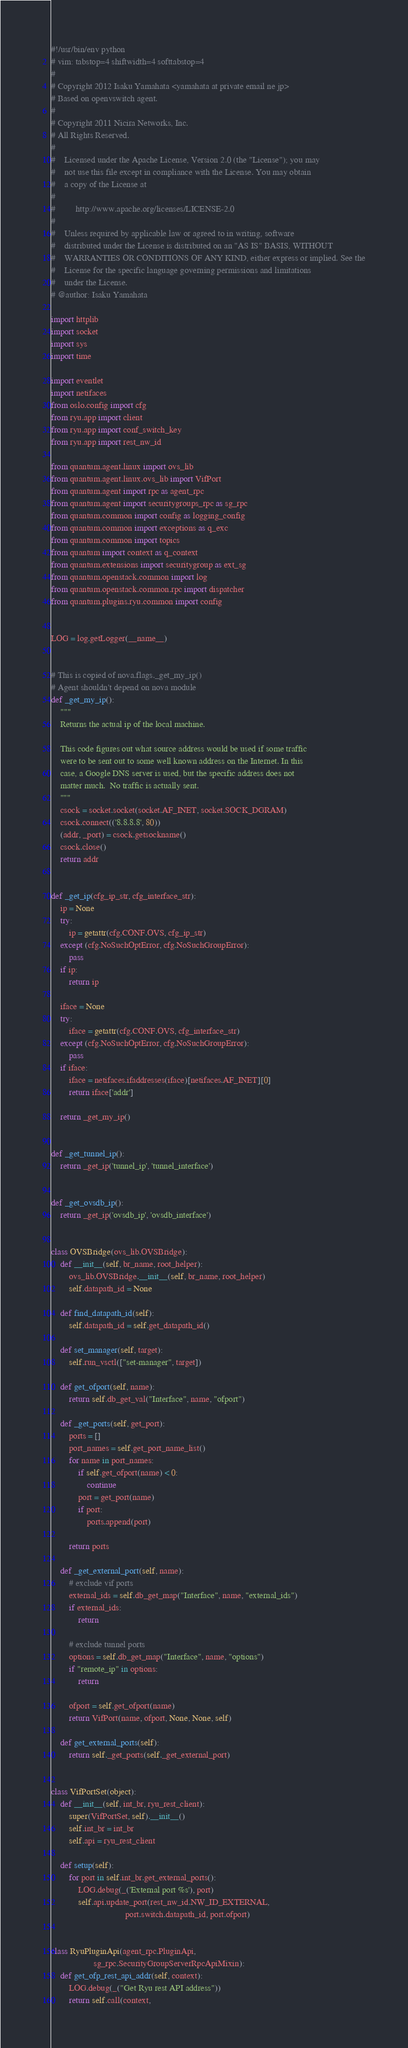Convert code to text. <code><loc_0><loc_0><loc_500><loc_500><_Python_>#!/usr/bin/env python
# vim: tabstop=4 shiftwidth=4 softtabstop=4
#
# Copyright 2012 Isaku Yamahata <yamahata at private email ne jp>
# Based on openvswitch agent.
#
# Copyright 2011 Nicira Networks, Inc.
# All Rights Reserved.
#
#    Licensed under the Apache License, Version 2.0 (the "License"); you may
#    not use this file except in compliance with the License. You may obtain
#    a copy of the License at
#
#         http://www.apache.org/licenses/LICENSE-2.0
#
#    Unless required by applicable law or agreed to in writing, software
#    distributed under the License is distributed on an "AS IS" BASIS, WITHOUT
#    WARRANTIES OR CONDITIONS OF ANY KIND, either express or implied. See the
#    License for the specific language governing permissions and limitations
#    under the License.
# @author: Isaku Yamahata

import httplib
import socket
import sys
import time

import eventlet
import netifaces
from oslo.config import cfg
from ryu.app import client
from ryu.app import conf_switch_key
from ryu.app import rest_nw_id

from quantum.agent.linux import ovs_lib
from quantum.agent.linux.ovs_lib import VifPort
from quantum.agent import rpc as agent_rpc
from quantum.agent import securitygroups_rpc as sg_rpc
from quantum.common import config as logging_config
from quantum.common import exceptions as q_exc
from quantum.common import topics
from quantum import context as q_context
from quantum.extensions import securitygroup as ext_sg
from quantum.openstack.common import log
from quantum.openstack.common.rpc import dispatcher
from quantum.plugins.ryu.common import config


LOG = log.getLogger(__name__)


# This is copied of nova.flags._get_my_ip()
# Agent shouldn't depend on nova module
def _get_my_ip():
    """
    Returns the actual ip of the local machine.

    This code figures out what source address would be used if some traffic
    were to be sent out to some well known address on the Internet. In this
    case, a Google DNS server is used, but the specific address does not
    matter much.  No traffic is actually sent.
    """
    csock = socket.socket(socket.AF_INET, socket.SOCK_DGRAM)
    csock.connect(('8.8.8.8', 80))
    (addr, _port) = csock.getsockname()
    csock.close()
    return addr


def _get_ip(cfg_ip_str, cfg_interface_str):
    ip = None
    try:
        ip = getattr(cfg.CONF.OVS, cfg_ip_str)
    except (cfg.NoSuchOptError, cfg.NoSuchGroupError):
        pass
    if ip:
        return ip

    iface = None
    try:
        iface = getattr(cfg.CONF.OVS, cfg_interface_str)
    except (cfg.NoSuchOptError, cfg.NoSuchGroupError):
        pass
    if iface:
        iface = netifaces.ifaddresses(iface)[netifaces.AF_INET][0]
        return iface['addr']

    return _get_my_ip()


def _get_tunnel_ip():
    return _get_ip('tunnel_ip', 'tunnel_interface')


def _get_ovsdb_ip():
    return _get_ip('ovsdb_ip', 'ovsdb_interface')


class OVSBridge(ovs_lib.OVSBridge):
    def __init__(self, br_name, root_helper):
        ovs_lib.OVSBridge.__init__(self, br_name, root_helper)
        self.datapath_id = None

    def find_datapath_id(self):
        self.datapath_id = self.get_datapath_id()

    def set_manager(self, target):
        self.run_vsctl(["set-manager", target])

    def get_ofport(self, name):
        return self.db_get_val("Interface", name, "ofport")

    def _get_ports(self, get_port):
        ports = []
        port_names = self.get_port_name_list()
        for name in port_names:
            if self.get_ofport(name) < 0:
                continue
            port = get_port(name)
            if port:
                ports.append(port)

        return ports

    def _get_external_port(self, name):
        # exclude vif ports
        external_ids = self.db_get_map("Interface", name, "external_ids")
        if external_ids:
            return

        # exclude tunnel ports
        options = self.db_get_map("Interface", name, "options")
        if "remote_ip" in options:
            return

        ofport = self.get_ofport(name)
        return VifPort(name, ofport, None, None, self)

    def get_external_ports(self):
        return self._get_ports(self._get_external_port)


class VifPortSet(object):
    def __init__(self, int_br, ryu_rest_client):
        super(VifPortSet, self).__init__()
        self.int_br = int_br
        self.api = ryu_rest_client

    def setup(self):
        for port in self.int_br.get_external_ports():
            LOG.debug(_('External port %s'), port)
            self.api.update_port(rest_nw_id.NW_ID_EXTERNAL,
                                 port.switch.datapath_id, port.ofport)


class RyuPluginApi(agent_rpc.PluginApi,
                   sg_rpc.SecurityGroupServerRpcApiMixin):
    def get_ofp_rest_api_addr(self, context):
        LOG.debug(_("Get Ryu rest API address"))
        return self.call(context,</code> 